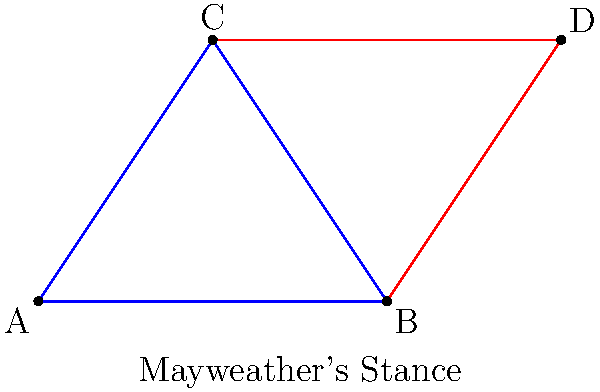In the diagram representing Mayweather's boxing stance, triangle ABC and triangle BCD are shown. Which criterion can be used to prove that these triangles are congruent? To determine if triangles ABC and BCD are congruent, we need to examine the given information and apply one of the congruence criteria. Let's analyze the triangles step by step:

1. Side BC is common to both triangles.

2. In Mayweather's stance, his shoulders are typically level, which suggests that AC is parallel to BD.

3. When a line is drawn parallel to one side of a triangle, it divides the other two sides proportionally. This means that AB:BD = AC:CD.

4. Since AC is parallel to BD, alternate angles are equal. Therefore, $\angle BAC = \angle BDC$ and $\angle ABC = \angle BCD$.

5. We now have:
   - One side is common (BC)
   - Two pairs of angles are equal ($\angle BAC = \angle BDC$ and $\angle ABC = \angle BCD$)

6. This information satisfies the AAS (Angle-Angle-Side) congruence criterion.

The AAS criterion states that if two angles and the non-included side of one triangle are equal to the corresponding parts of another triangle, the triangles are congruent.
Answer: AAS (Angle-Angle-Side) 